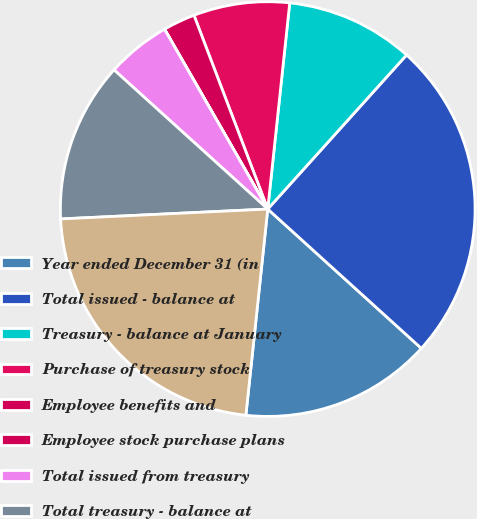<chart> <loc_0><loc_0><loc_500><loc_500><pie_chart><fcel>Year ended December 31 (in<fcel>Total issued - balance at<fcel>Treasury - balance at January<fcel>Purchase of treasury stock<fcel>Employee benefits and<fcel>Employee stock purchase plans<fcel>Total issued from treasury<fcel>Total treasury - balance at<fcel>Outstanding<nl><fcel>14.96%<fcel>25.05%<fcel>9.98%<fcel>7.48%<fcel>2.5%<fcel>0.01%<fcel>4.99%<fcel>12.47%<fcel>22.56%<nl></chart> 